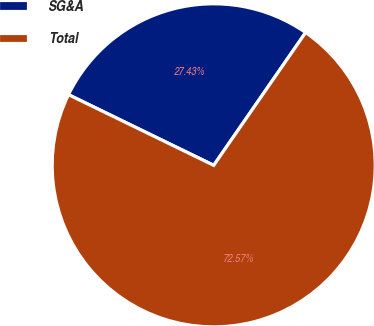Convert chart. <chart><loc_0><loc_0><loc_500><loc_500><pie_chart><fcel>SG&A<fcel>Total<nl><fcel>27.43%<fcel>72.57%<nl></chart> 